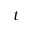Convert formula to latex. <formula><loc_0><loc_0><loc_500><loc_500>t</formula> 